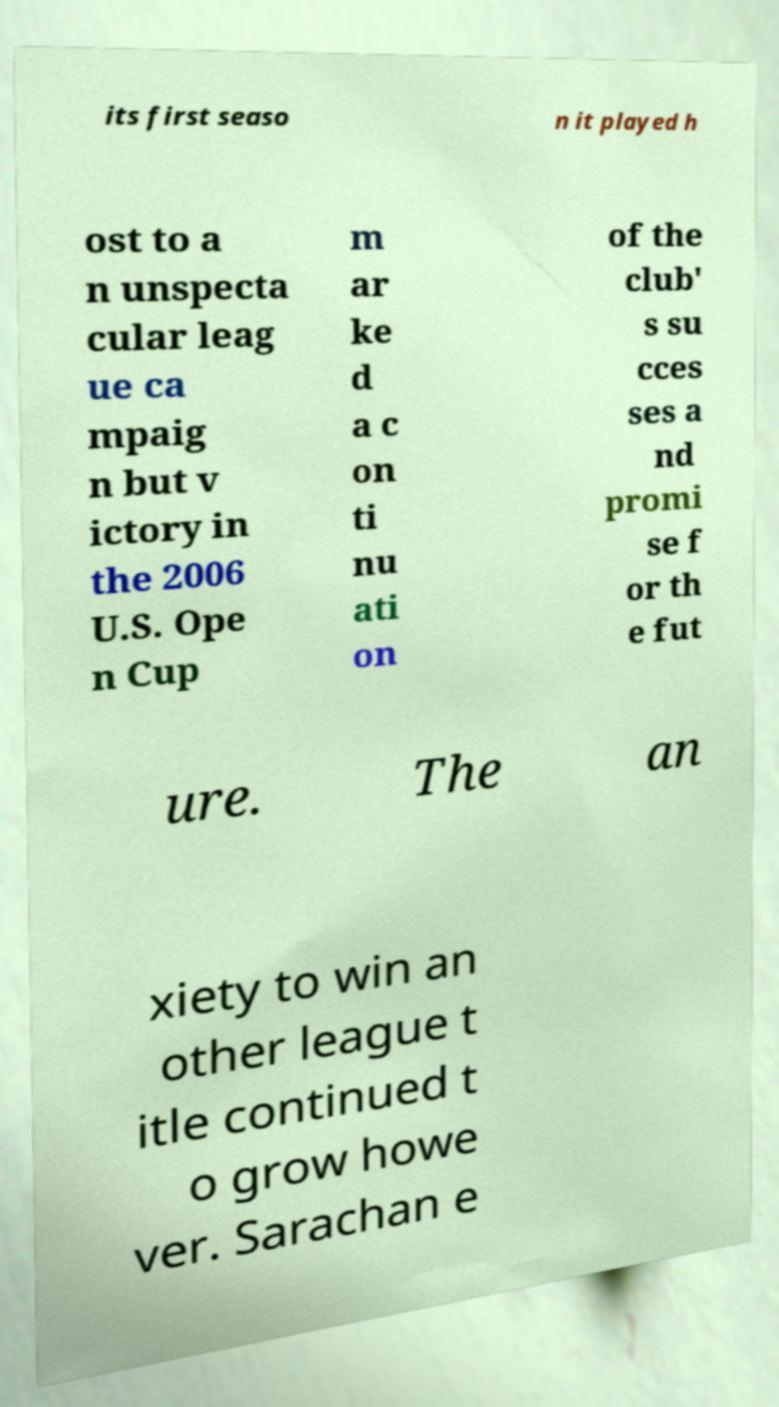Can you read and provide the text displayed in the image?This photo seems to have some interesting text. Can you extract and type it out for me? its first seaso n it played h ost to a n unspecta cular leag ue ca mpaig n but v ictory in the 2006 U.S. Ope n Cup m ar ke d a c on ti nu ati on of the club' s su cces ses a nd promi se f or th e fut ure. The an xiety to win an other league t itle continued t o grow howe ver. Sarachan e 